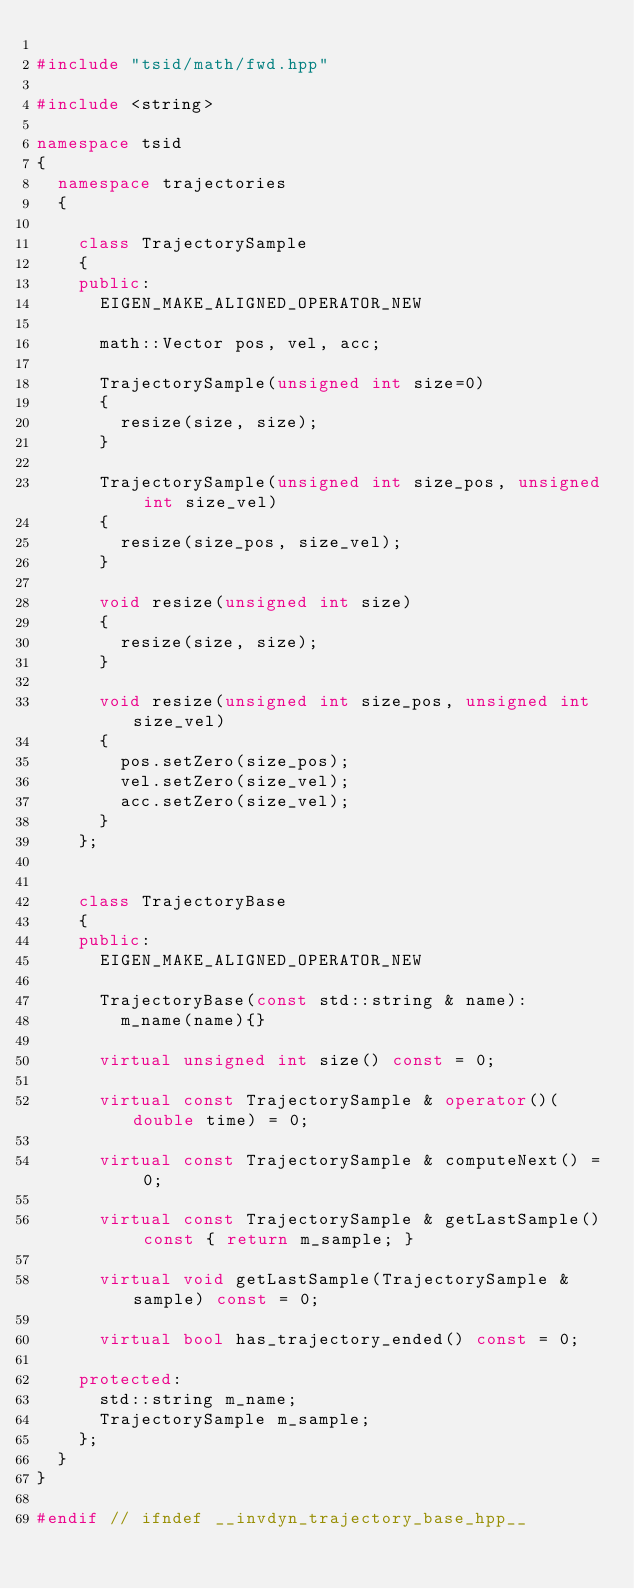<code> <loc_0><loc_0><loc_500><loc_500><_C++_>
#include "tsid/math/fwd.hpp"

#include <string>

namespace tsid
{
  namespace trajectories
  {
    
    class TrajectorySample
    {
    public:
      EIGEN_MAKE_ALIGNED_OPERATOR_NEW
      
      math::Vector pos, vel, acc;

      TrajectorySample(unsigned int size=0)
      {
        resize(size, size);
      }

      TrajectorySample(unsigned int size_pos, unsigned int size_vel)
      {
        resize(size_pos, size_vel);
      }

      void resize(unsigned int size)
      {
        resize(size, size);
      }

      void resize(unsigned int size_pos, unsigned int size_vel)
      {
        pos.setZero(size_pos);
        vel.setZero(size_vel);
        acc.setZero(size_vel);
      }
    };


    class TrajectoryBase
    {
    public:
      EIGEN_MAKE_ALIGNED_OPERATOR_NEW

      TrajectoryBase(const std::string & name):
        m_name(name){}

      virtual unsigned int size() const = 0;

      virtual const TrajectorySample & operator()(double time) = 0;

      virtual const TrajectorySample & computeNext() = 0;

      virtual const TrajectorySample & getLastSample() const { return m_sample; }

      virtual void getLastSample(TrajectorySample & sample) const = 0;

      virtual bool has_trajectory_ended() const = 0;

    protected:
      std::string m_name;
      TrajectorySample m_sample;
    };
  }
}

#endif // ifndef __invdyn_trajectory_base_hpp__
</code> 